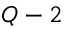Convert formula to latex. <formula><loc_0><loc_0><loc_500><loc_500>Q - 2</formula> 